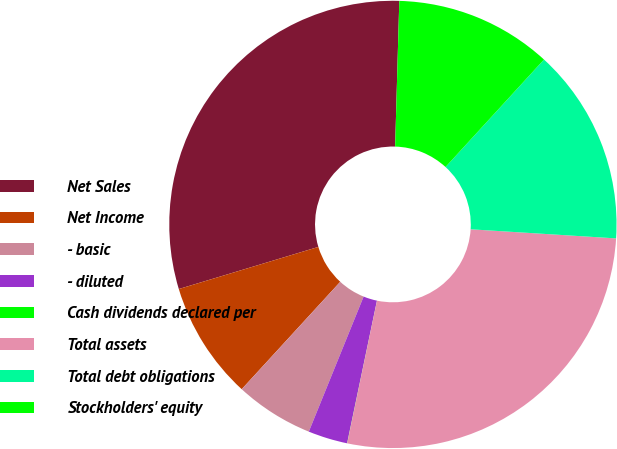<chart> <loc_0><loc_0><loc_500><loc_500><pie_chart><fcel>Net Sales<fcel>Net Income<fcel>- basic<fcel>- diluted<fcel>Cash dividends declared per<fcel>Total assets<fcel>Total debt obligations<fcel>Stockholders' equity<nl><fcel>30.12%<fcel>8.52%<fcel>5.68%<fcel>2.85%<fcel>0.01%<fcel>27.28%<fcel>14.19%<fcel>11.35%<nl></chart> 